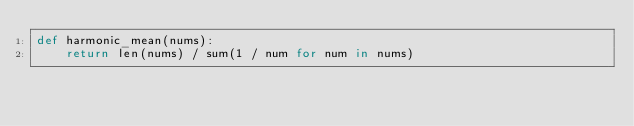<code> <loc_0><loc_0><loc_500><loc_500><_Cython_>def harmonic_mean(nums):
    return len(nums) / sum(1 / num for num in nums)
</code> 